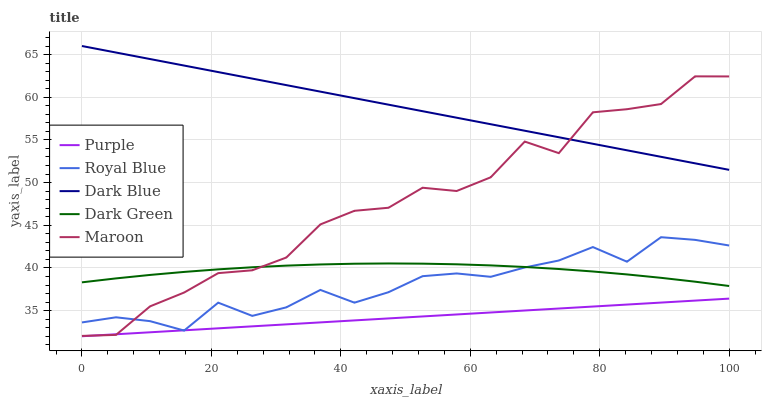Does Royal Blue have the minimum area under the curve?
Answer yes or no. No. Does Royal Blue have the maximum area under the curve?
Answer yes or no. No. Is Royal Blue the smoothest?
Answer yes or no. No. Is Royal Blue the roughest?
Answer yes or no. No. Does Royal Blue have the lowest value?
Answer yes or no. No. Does Royal Blue have the highest value?
Answer yes or no. No. Is Royal Blue less than Dark Blue?
Answer yes or no. Yes. Is Dark Green greater than Purple?
Answer yes or no. Yes. Does Royal Blue intersect Dark Blue?
Answer yes or no. No. 